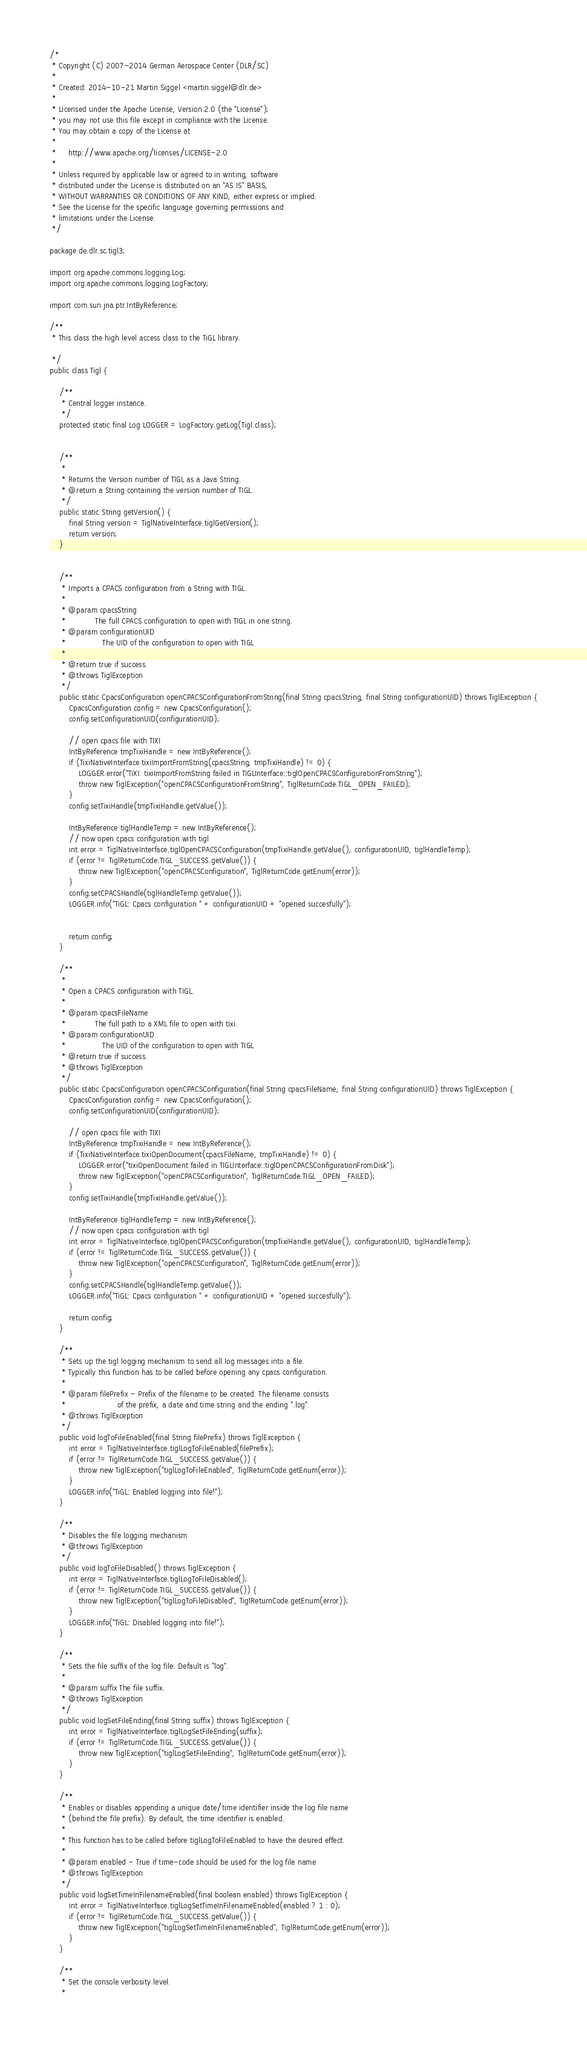Convert code to text. <code><loc_0><loc_0><loc_500><loc_500><_Java_>/* 
 * Copyright (C) 2007-2014 German Aerospace Center (DLR/SC)
 *
 * Created: 2014-10-21 Martin Siggel <martin.siggel@dlr.de>
 *
 * Licensed under the Apache License, Version 2.0 (the "License");
 * you may not use this file except in compliance with the License.
 * You may obtain a copy of the License at
 *
 *     http://www.apache.org/licenses/LICENSE-2.0
 *
 * Unless required by applicable law or agreed to in writing, software
 * distributed under the License is distributed on an "AS IS" BASIS,
 * WITHOUT WARRANTIES OR CONDITIONS OF ANY KIND, either express or implied.
 * See the License for the specific language governing permissions and
 * limitations under the License.
 */

package de.dlr.sc.tigl3;

import org.apache.commons.logging.Log;
import org.apache.commons.logging.LogFactory;

import com.sun.jna.ptr.IntByReference;

/**
 * This class the high level access class to the TiGL library.

 */
public class Tigl {
	
    /**
     * Central logger instance.
     */
    protected static final Log LOGGER = LogFactory.getLog(Tigl.class);

    
    /**
     * 
     * Returns the Version number of TIGL as a Java String.
     * @return a String containing the version number of TIGL.
     */
    public static String getVersion() {
        final String version = TiglNativeInterface.tiglGetVersion();
        return version;
    }
    
    
    /**
     * Imports a CPACS configuration from a String with TIGL.
     * 
     * @param cpacsString
     *            The full CPACS configuration to open with TIGL in one string.
     * @param configurationUID
     *               The UID of the configuration to open with TIGL         
     *         
     * @return true if success.
     * @throws TiglException 
     */
    public static CpacsConfiguration openCPACSConfigurationFromString(final String cpacsString, final String configurationUID) throws TiglException {
        CpacsConfiguration config = new CpacsConfiguration();
        config.setConfigurationUID(configurationUID);

        // open cpacs file with TIXI
        IntByReference tmpTixiHandle = new IntByReference();
        if (TixiNativeInterface.tixiImportFromString(cpacsString, tmpTixiHandle) != 0) {
            LOGGER.error("TiXI: tixiImportFromString failed in TIGLInterface::tiglOpenCPACSConfigurationFromString");
            throw new TiglException("openCPACSConfigurationFromString", TiglReturnCode.TIGL_OPEN_FAILED);
        }    
        config.setTixiHandle(tmpTixiHandle.getValue());

        IntByReference tiglHandleTemp = new IntByReference();
        // now open cpacs configuration with tigl        
        int error = TiglNativeInterface.tiglOpenCPACSConfiguration(tmpTixiHandle.getValue(), configurationUID, tiglHandleTemp); 
        if (error != TiglReturnCode.TIGL_SUCCESS.getValue()) {
        	throw new TiglException("openCPACSConfiguration", TiglReturnCode.getEnum(error));
        }
        config.setCPACSHandle(tiglHandleTemp.getValue());
        LOGGER.info("TiGL: Cpacs configuration " + configurationUID + "opened succesfully");
        
        
        return config;
    }

    /**
     * 
     * Open a CPACS configuration with TIGL.
     * 
     * @param cpacsFileName
     *            The full path to a XML file to open with tixi.
     * @param configurationUID
     *               The UID of the configuration to open with TIGL     
     * @return true if success.
     * @throws TiglException 
     */
    public static CpacsConfiguration openCPACSConfiguration(final String cpacsFileName, final String configurationUID) throws TiglException {
        CpacsConfiguration config = new CpacsConfiguration();
    	config.setConfigurationUID(configurationUID);

        // open cpacs file with TIXI
        IntByReference tmpTixiHandle = new IntByReference();
        if (TixiNativeInterface.tixiOpenDocument(cpacsFileName, tmpTixiHandle) != 0) {
            LOGGER.error("tixiOpenDocument failed in TIGLInterface::tiglOpenCPACSConfigurationFromDisk");
            throw new TiglException("openCPACSConfiguration", TiglReturnCode.TIGL_OPEN_FAILED);
        }    
        config.setTixiHandle(tmpTixiHandle.getValue());

        IntByReference tiglHandleTemp = new IntByReference();
        // now open cpacs configuration with tigl        
        int error = TiglNativeInterface.tiglOpenCPACSConfiguration(tmpTixiHandle.getValue(), configurationUID, tiglHandleTemp); 
        if (error != TiglReturnCode.TIGL_SUCCESS.getValue()) {
            throw new TiglException("openCPACSConfiguration", TiglReturnCode.getEnum(error));
        }
        config.setCPACSHandle(tiglHandleTemp.getValue());
        LOGGER.info("TiGL: Cpacs configuration " + configurationUID + "opened succesfully");

        return config;
    }
    
    /**
     * Sets up the tigl logging mechanism to send all log messages into a file.
     * Typically this function has to be called before opening any cpacs configuration.
     *  
     * @param filePrefix - Prefix of the filename to be created. The filename consists 
     *                     of the prefix, a date and time string and the ending ".log".
     * @throws TiglException
     */
    public void logToFileEnabled(final String filePrefix) throws TiglException {
        int error = TiglNativeInterface.tiglLogToFileEnabled(filePrefix);
        if (error != TiglReturnCode.TIGL_SUCCESS.getValue()) {
            throw new TiglException("tiglLogToFileEnabled", TiglReturnCode.getEnum(error));
        }
        LOGGER.info("TiGL: Enabled logging into file!");
    }
    
    /**
     * Disables the file logging mechanism
     * @throws TiglException
     */
    public void logToFileDisabled() throws TiglException {
        int error = TiglNativeInterface.tiglLogToFileDisabled();
        if (error != TiglReturnCode.TIGL_SUCCESS.getValue()) {
            throw new TiglException("tiglLogToFileDisabled", TiglReturnCode.getEnum(error));
        }
        LOGGER.info("TiGL: Disabled logging into file!");
    }
    
    /**
     * Sets the file suffix of the log file. Default is "log".
     *  
     * @param suffix The file suffix.
     * @throws TiglException
     */
    public void logSetFileEnding(final String suffix) throws TiglException {
        int error = TiglNativeInterface.tiglLogSetFileEnding(suffix);
        if (error != TiglReturnCode.TIGL_SUCCESS.getValue()) {
            throw new TiglException("tiglLogSetFileEnding", TiglReturnCode.getEnum(error));
        }
    }
    
    /**
     * Enables or disables appending a unique date/time identifier inside the log file name 
     * (behind the file prefix). By default, the time identifier is enabled.
     *
     * This function has to be called before tiglLogToFileEnabled to have the desired effect.
     * 
     * @param enabled - True if time-code should be used for the log file name
     * @throws TiglException
     */
    public void logSetTimeInFilenameEnabled(final boolean enabled) throws TiglException {
        int error = TiglNativeInterface.tiglLogSetTimeInFilenameEnabled(enabled ? 1 : 0);
        if (error != TiglReturnCode.TIGL_SUCCESS.getValue()) {
            throw new TiglException("tiglLogSetTimeInFilenameEnabled", TiglReturnCode.getEnum(error));
        }
    }

    /**
     * Set the console verbosity level.
     *</code> 